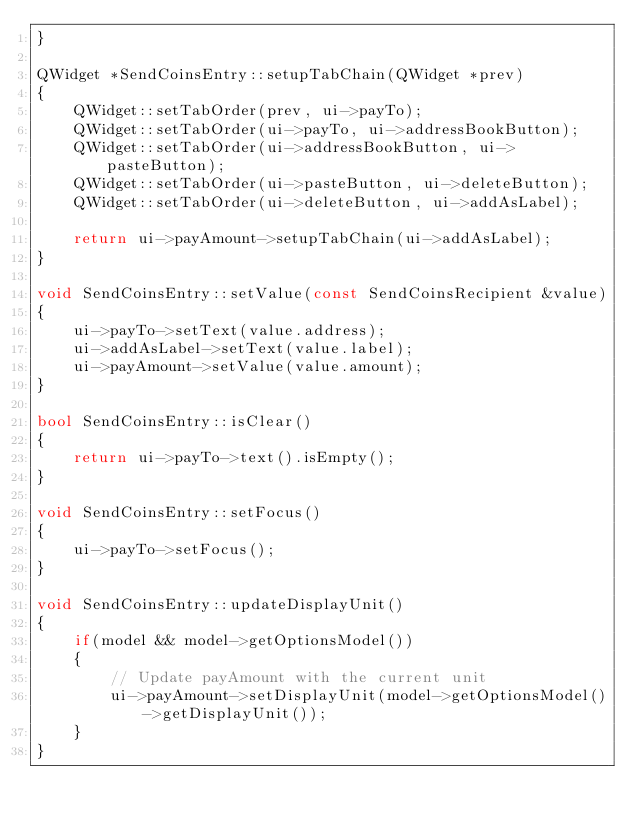<code> <loc_0><loc_0><loc_500><loc_500><_C++_>}

QWidget *SendCoinsEntry::setupTabChain(QWidget *prev)
{
	QWidget::setTabOrder(prev, ui->payTo);
    QWidget::setTabOrder(ui->payTo, ui->addressBookButton);
    QWidget::setTabOrder(ui->addressBookButton, ui->pasteButton);
    QWidget::setTabOrder(ui->pasteButton, ui->deleteButton);
    QWidget::setTabOrder(ui->deleteButton, ui->addAsLabel);

	return ui->payAmount->setupTabChain(ui->addAsLabel);
}

void SendCoinsEntry::setValue(const SendCoinsRecipient &value)
{
    ui->payTo->setText(value.address);
    ui->addAsLabel->setText(value.label);
    ui->payAmount->setValue(value.amount);
}

bool SendCoinsEntry::isClear()
{
    return ui->payTo->text().isEmpty();
}

void SendCoinsEntry::setFocus()
{
    ui->payTo->setFocus();
}

void SendCoinsEntry::updateDisplayUnit()
{
    if(model && model->getOptionsModel())
    {
        // Update payAmount with the current unit
        ui->payAmount->setDisplayUnit(model->getOptionsModel()->getDisplayUnit());
    }
}
</code> 